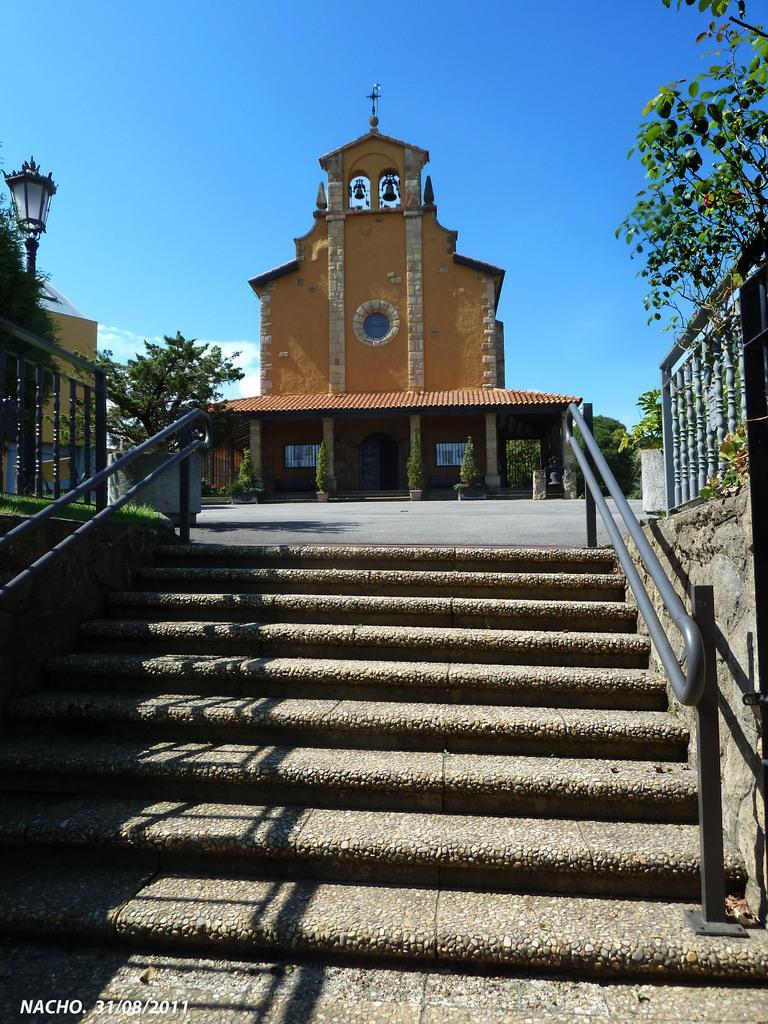How would you summarize this image in a sentence or two? This image consists of a building. At the bottom, there are steps along with railing. On the left and right, there are trees. At the top, there is sky. 